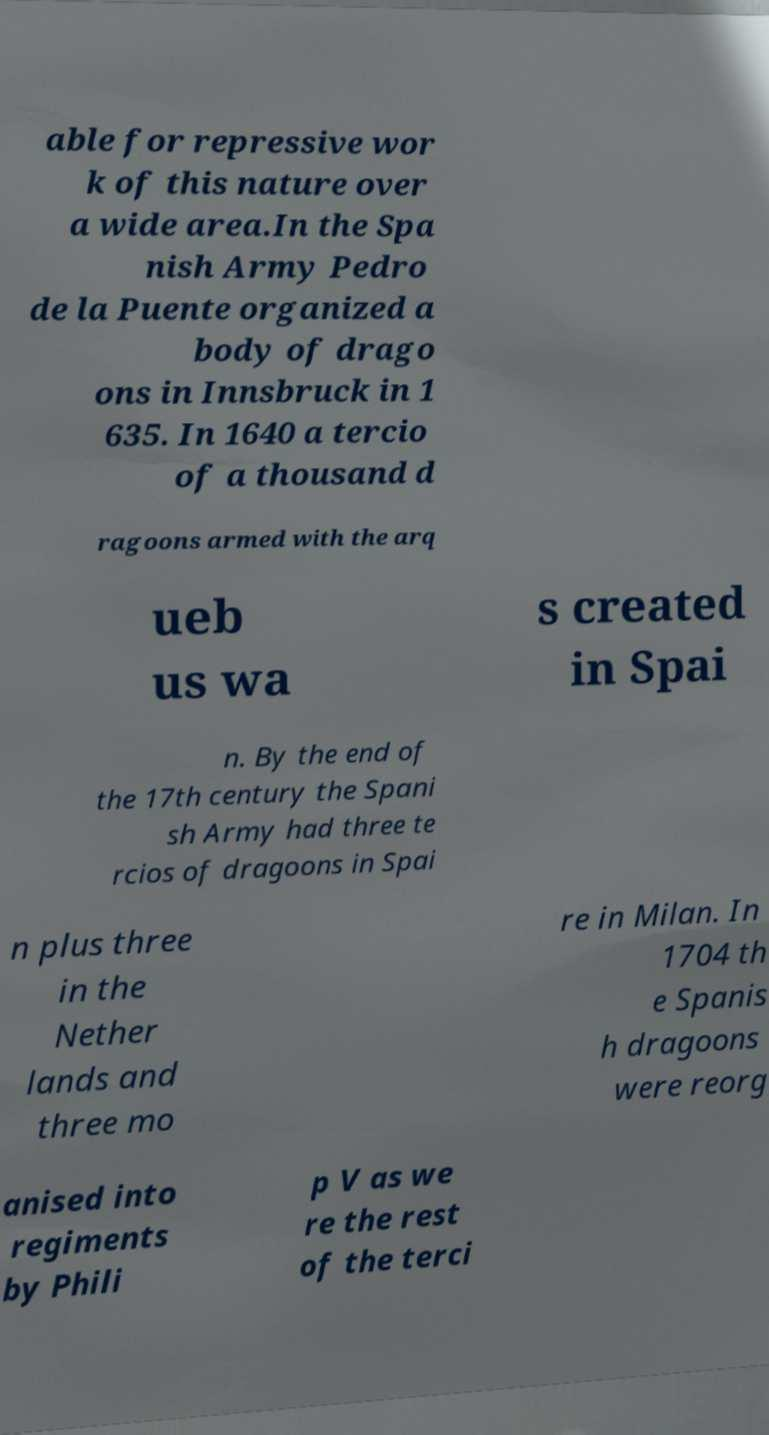Please identify and transcribe the text found in this image. able for repressive wor k of this nature over a wide area.In the Spa nish Army Pedro de la Puente organized a body of drago ons in Innsbruck in 1 635. In 1640 a tercio of a thousand d ragoons armed with the arq ueb us wa s created in Spai n. By the end of the 17th century the Spani sh Army had three te rcios of dragoons in Spai n plus three in the Nether lands and three mo re in Milan. In 1704 th e Spanis h dragoons were reorg anised into regiments by Phili p V as we re the rest of the terci 